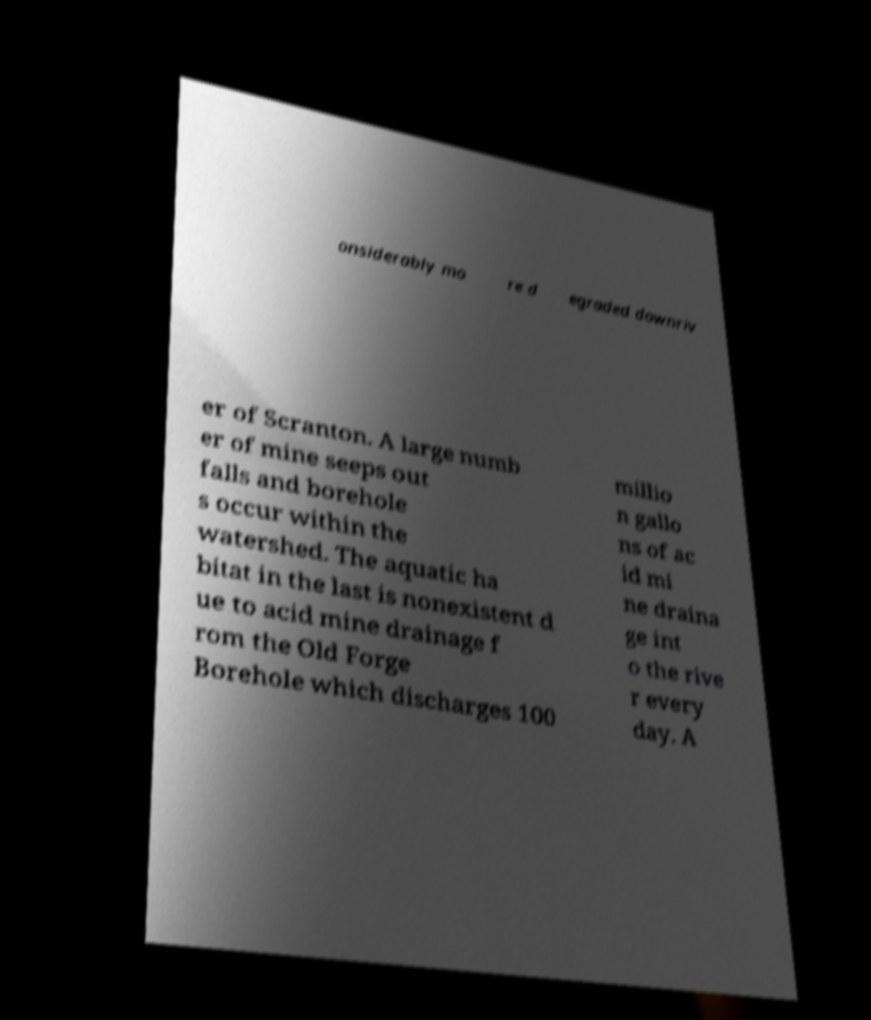Can you accurately transcribe the text from the provided image for me? onsiderably mo re d egraded downriv er of Scranton. A large numb er of mine seeps out falls and borehole s occur within the watershed. The aquatic ha bitat in the last is nonexistent d ue to acid mine drainage f rom the Old Forge Borehole which discharges 100 millio n gallo ns of ac id mi ne draina ge int o the rive r every day. A 